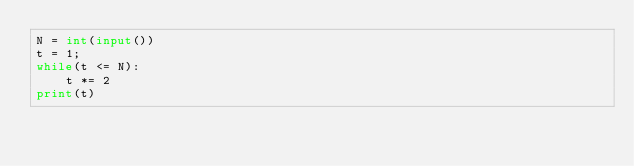<code> <loc_0><loc_0><loc_500><loc_500><_Python_>N = int(input())
t = 1;
while(t <= N):
    t *= 2
print(t)</code> 